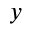Convert formula to latex. <formula><loc_0><loc_0><loc_500><loc_500>y</formula> 